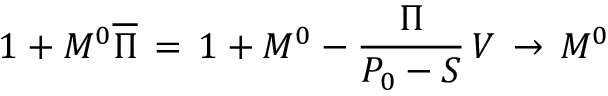<formula> <loc_0><loc_0><loc_500><loc_500>1 + M ^ { 0 } \overline { \Pi } \, = \, 1 + M ^ { 0 } - { \frac { \Pi } { P _ { 0 } - S } } \, V \, \to \, M ^ { 0 }</formula> 